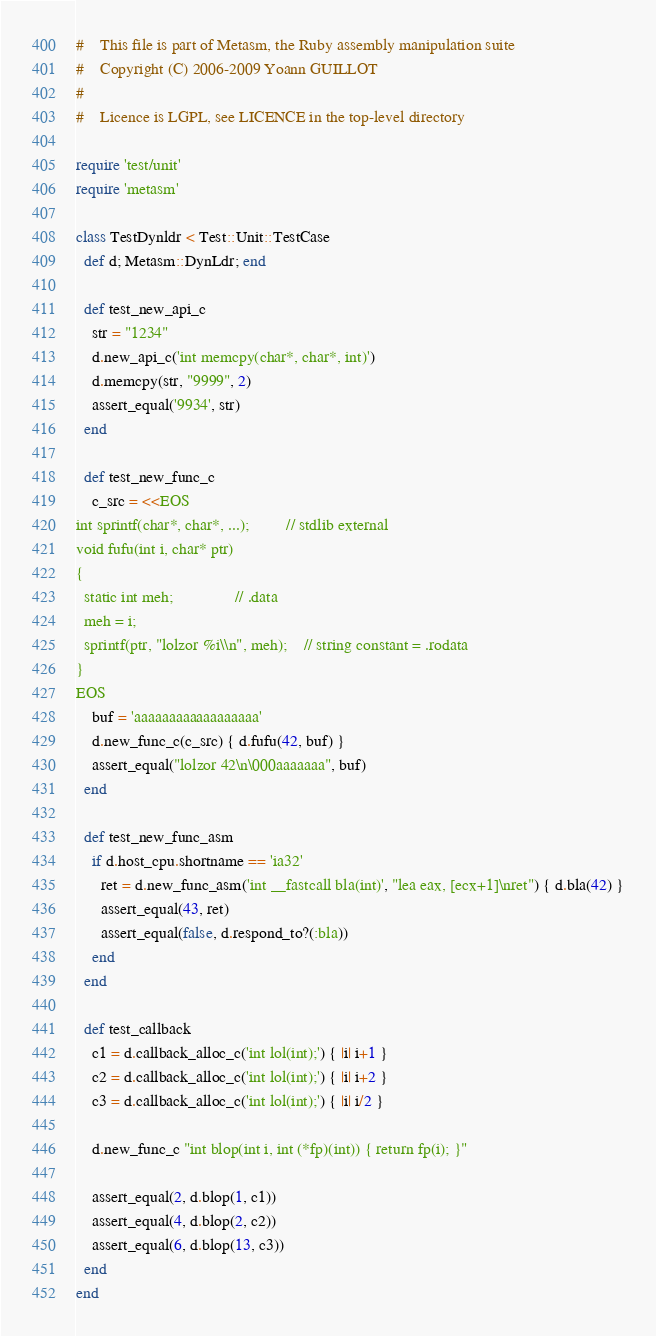<code> <loc_0><loc_0><loc_500><loc_500><_Ruby_>#    This file is part of Metasm, the Ruby assembly manipulation suite
#    Copyright (C) 2006-2009 Yoann GUILLOT
#
#    Licence is LGPL, see LICENCE in the top-level directory

require 'test/unit'
require 'metasm'

class TestDynldr < Test::Unit::TestCase
  def d; Metasm::DynLdr; end

  def test_new_api_c
    str = "1234"
    d.new_api_c('int memcpy(char*, char*, int)')
    d.memcpy(str, "9999", 2)
    assert_equal('9934', str)
  end

  def test_new_func_c
    c_src = <<EOS
int sprintf(char*, char*, ...);			// stdlib external
void fufu(int i, char* ptr)
{
  static int meh;				// .data
  meh = i;
  sprintf(ptr, "lolzor %i\\n", meh);	// string constant = .rodata
}
EOS
    buf = 'aaaaaaaaaaaaaaaaaa'
    d.new_func_c(c_src) { d.fufu(42, buf) }
    assert_equal("lolzor 42\n\000aaaaaaa", buf)
  end

  def test_new_func_asm
    if d.host_cpu.shortname == 'ia32'
      ret = d.new_func_asm('int __fastcall bla(int)', "lea eax, [ecx+1]\nret") { d.bla(42) }
      assert_equal(43, ret)
      assert_equal(false, d.respond_to?(:bla))
    end
  end

  def test_callback
    c1 = d.callback_alloc_c('int lol(int);') { |i| i+1 }
    c2 = d.callback_alloc_c('int lol(int);') { |i| i+2 }
    c3 = d.callback_alloc_c('int lol(int);') { |i| i/2 }

    d.new_func_c "int blop(int i, int (*fp)(int)) { return fp(i); }"
    
    assert_equal(2, d.blop(1, c1))
    assert_equal(4, d.blop(2, c2))
    assert_equal(6, d.blop(13, c3))
  end
end
</code> 